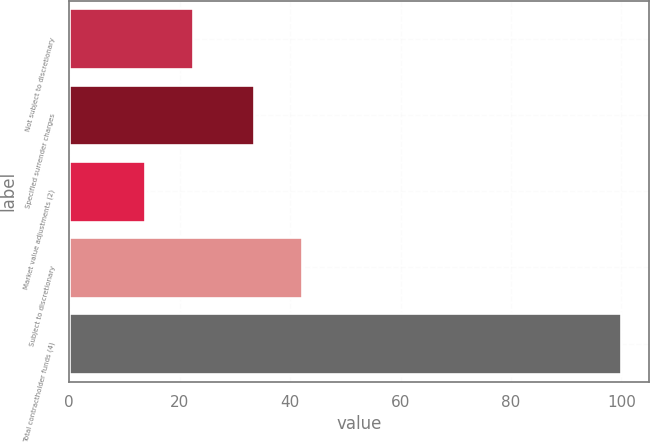Convert chart. <chart><loc_0><loc_0><loc_500><loc_500><bar_chart><fcel>Not subject to discretionary<fcel>Specified surrender charges<fcel>Market value adjustments (2)<fcel>Subject to discretionary<fcel>Total contractholder funds (4)<nl><fcel>22.33<fcel>33.5<fcel>13.7<fcel>42.13<fcel>100<nl></chart> 